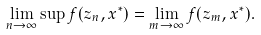<formula> <loc_0><loc_0><loc_500><loc_500>\lim _ { n \to \infty } \sup f ( z _ { n } , x ^ { * } ) = \lim _ { m \to \infty } f ( z _ { m } , x ^ { * } ) .</formula> 